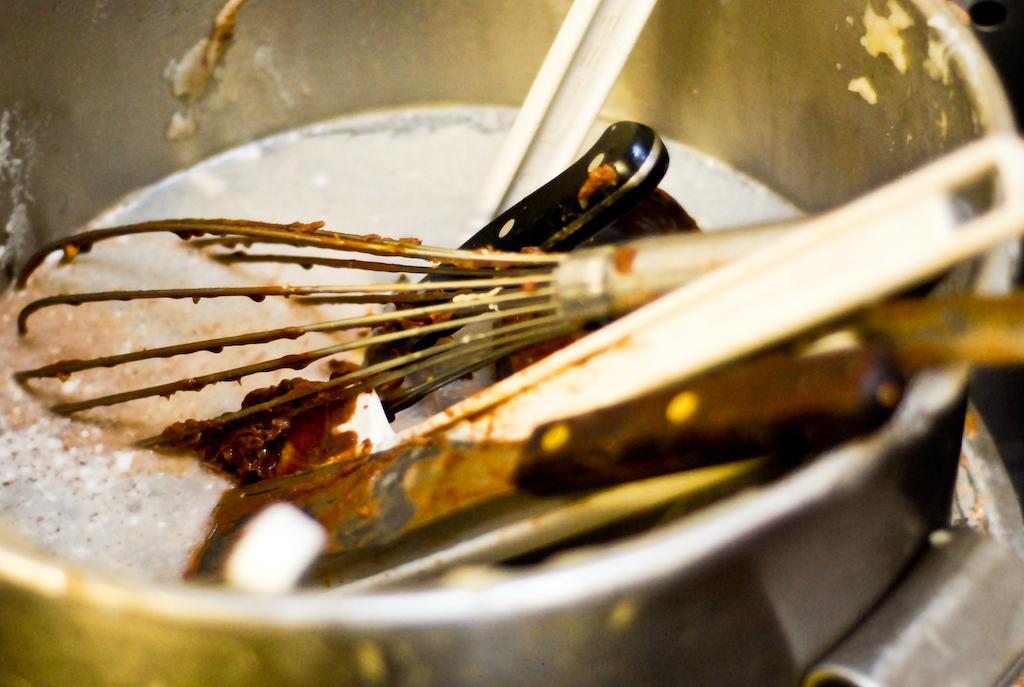Could you give a brief overview of what you see in this image? In this image I can see a bowl in which a knife and few spoons are placed. 